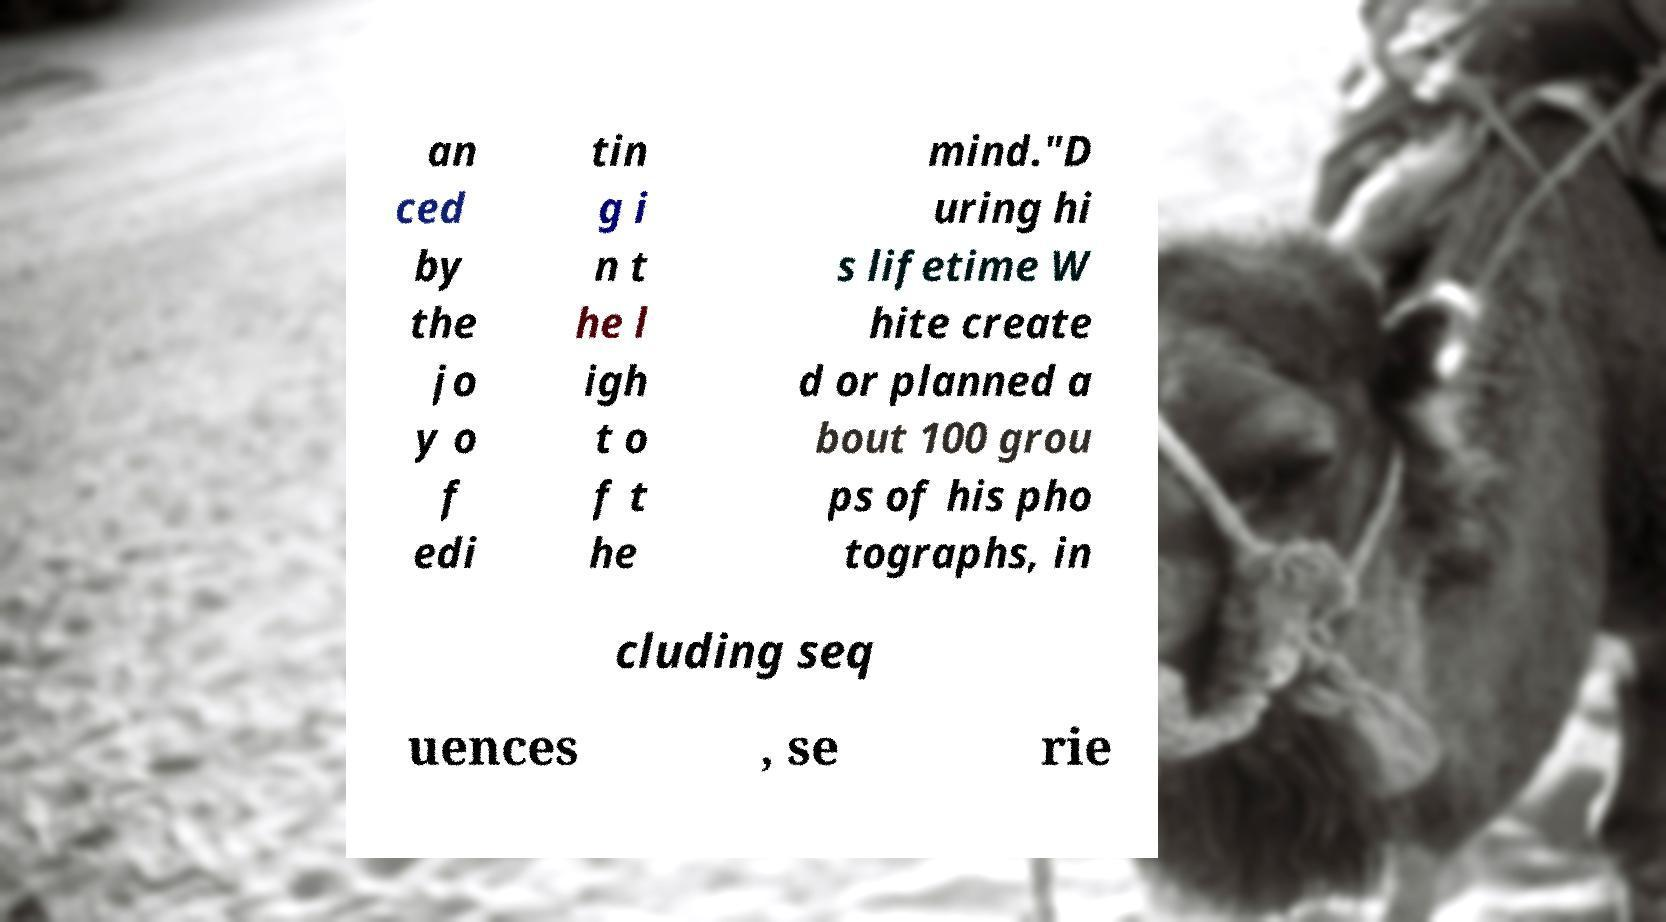For documentation purposes, I need the text within this image transcribed. Could you provide that? an ced by the jo y o f edi tin g i n t he l igh t o f t he mind."D uring hi s lifetime W hite create d or planned a bout 100 grou ps of his pho tographs, in cluding seq uences , se rie 